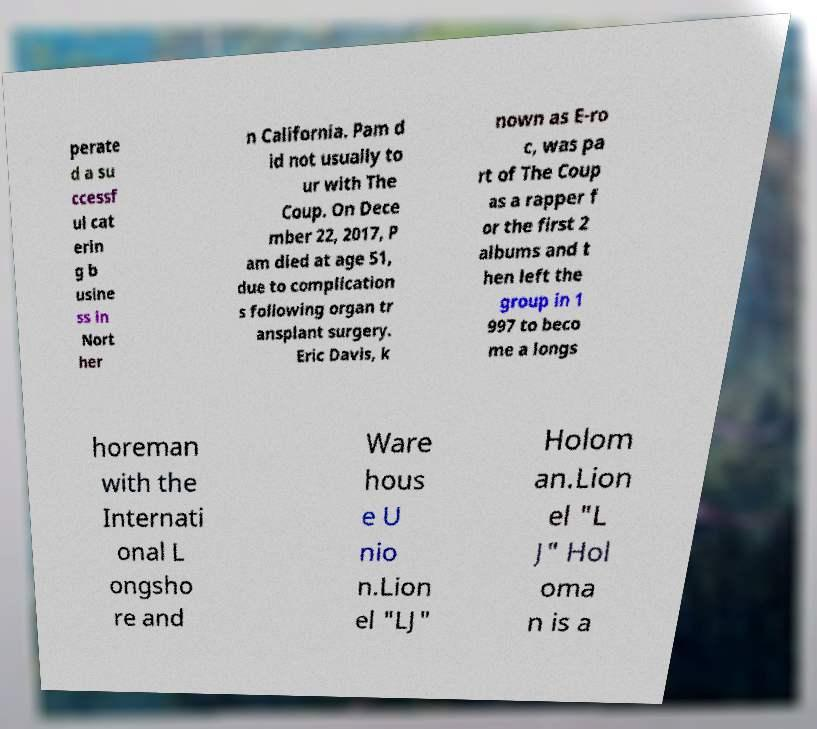Please identify and transcribe the text found in this image. perate d a su ccessf ul cat erin g b usine ss in Nort her n California. Pam d id not usually to ur with The Coup. On Dece mber 22, 2017, P am died at age 51, due to complication s following organ tr ansplant surgery. Eric Davis, k nown as E-ro c, was pa rt of The Coup as a rapper f or the first 2 albums and t hen left the group in 1 997 to beco me a longs horeman with the Internati onal L ongsho re and Ware hous e U nio n.Lion el "LJ" Holom an.Lion el "L J" Hol oma n is a 